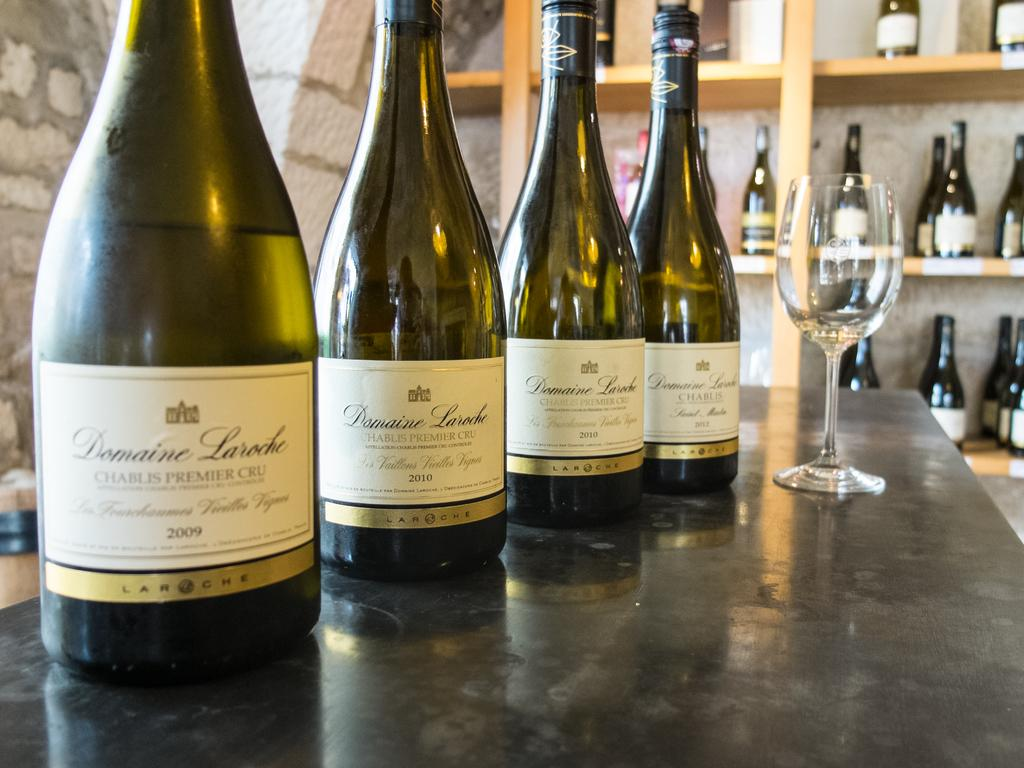<image>
Describe the image concisely. Four bottles of Domaine Laroche Chablis Premier Cru from 2009, 2010, and 2012 are displayed with a wine glass. 